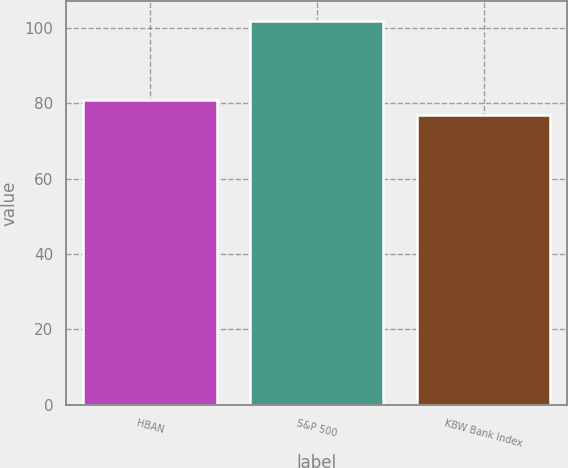<chart> <loc_0><loc_0><loc_500><loc_500><bar_chart><fcel>HBAN<fcel>S&P 500<fcel>KBW Bank Index<nl><fcel>81<fcel>102<fcel>77<nl></chart> 